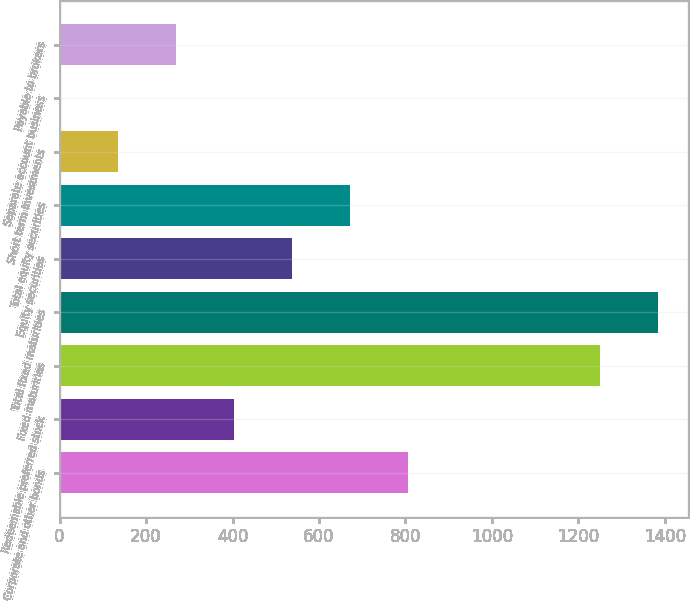Convert chart. <chart><loc_0><loc_0><loc_500><loc_500><bar_chart><fcel>Corporate and other bonds<fcel>Redeemable preferred stock<fcel>Fixed maturities<fcel>Total fixed maturities<fcel>Equity securities<fcel>Total equity securities<fcel>Short term investments<fcel>Separate account business<fcel>Payable to brokers<nl><fcel>804.8<fcel>403.4<fcel>1251<fcel>1384.8<fcel>537.2<fcel>671<fcel>135.8<fcel>2<fcel>269.6<nl></chart> 